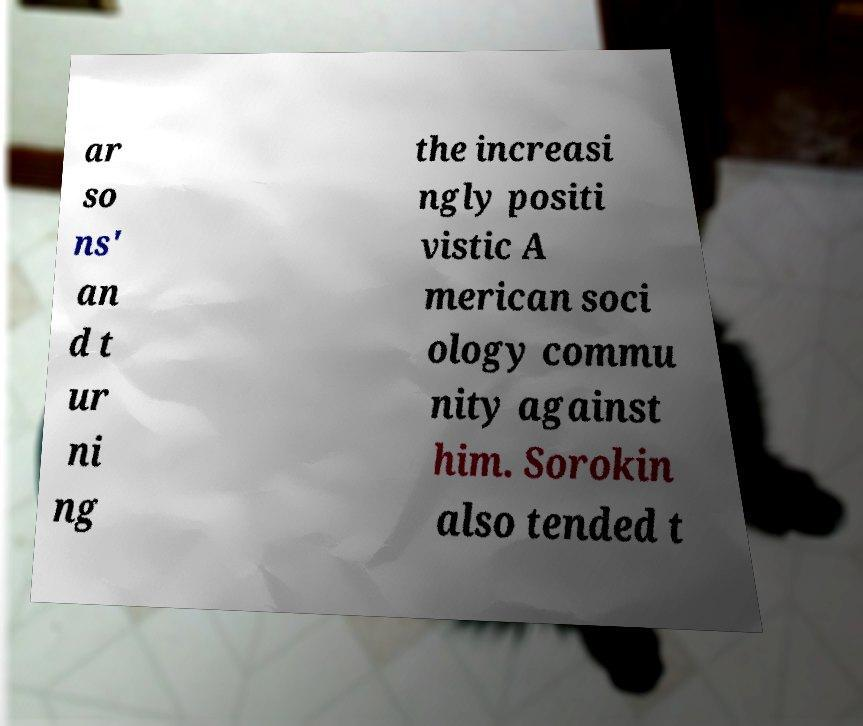There's text embedded in this image that I need extracted. Can you transcribe it verbatim? ar so ns' an d t ur ni ng the increasi ngly positi vistic A merican soci ology commu nity against him. Sorokin also tended t 